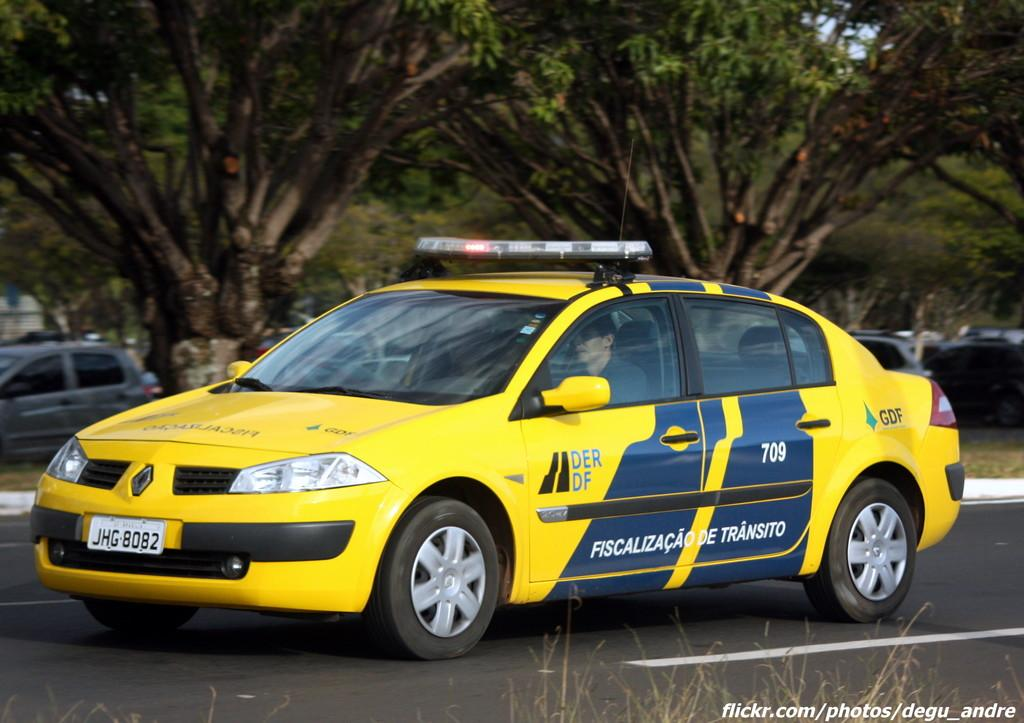<image>
Render a clear and concise summary of the photo. A primarily yellow car has flashing lights on the room and the license plate JHG 8082. 